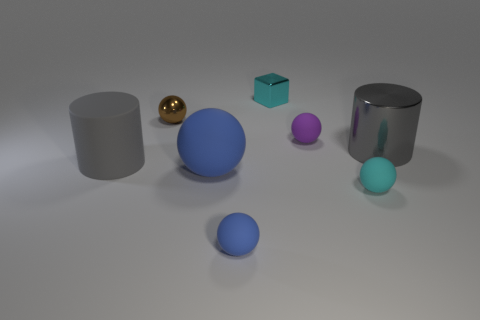Subtract all tiny blue spheres. How many spheres are left? 4 Subtract 2 balls. How many balls are left? 3 Subtract all brown balls. How many balls are left? 4 Subtract all green spheres. Subtract all red cylinders. How many spheres are left? 5 Add 1 big green metallic cubes. How many objects exist? 9 Subtract all cylinders. How many objects are left? 6 Subtract 0 brown blocks. How many objects are left? 8 Subtract all tiny brown balls. Subtract all big matte cylinders. How many objects are left? 6 Add 5 metallic cylinders. How many metallic cylinders are left? 6 Add 4 small cyan metal cubes. How many small cyan metal cubes exist? 5 